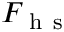Convert formula to latex. <formula><loc_0><loc_0><loc_500><loc_500>F _ { h s }</formula> 